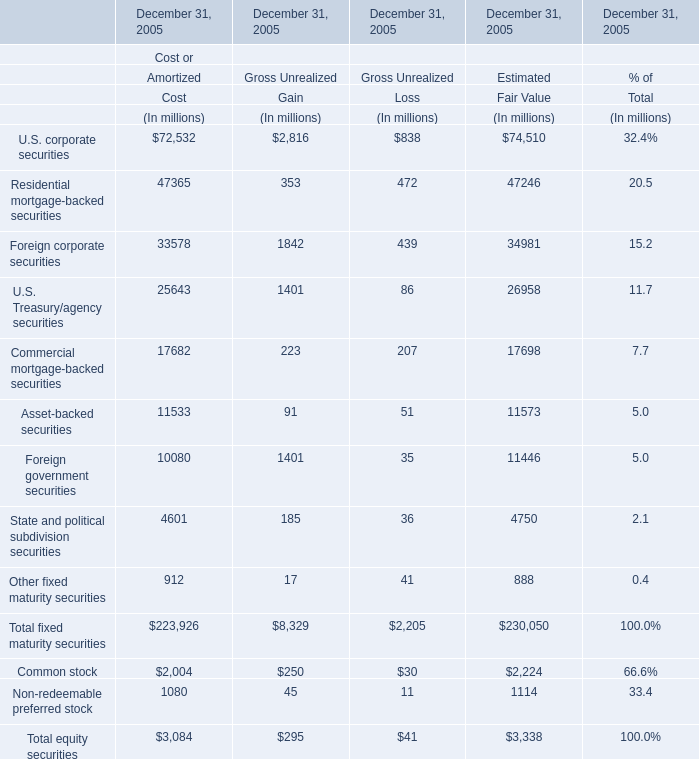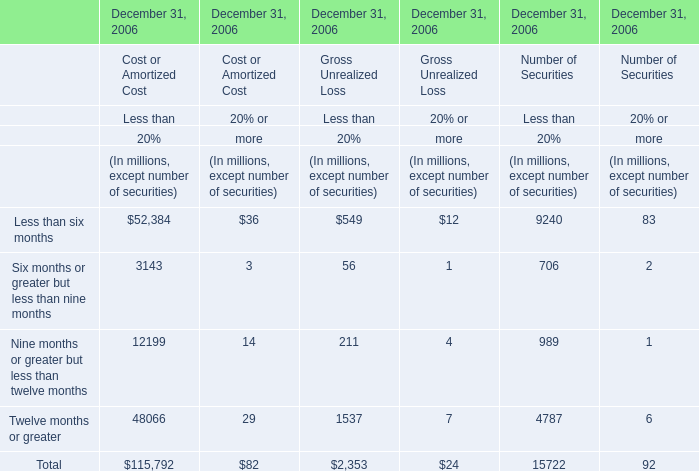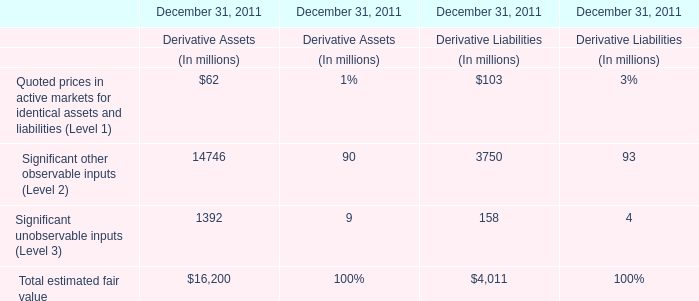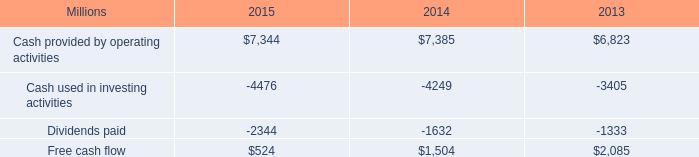What was the total amount of fixed maturity securities at Estimated Fair Value at December 31, 2005 excluding those less than 70000 million? (in million) 
Answer: 74510. 